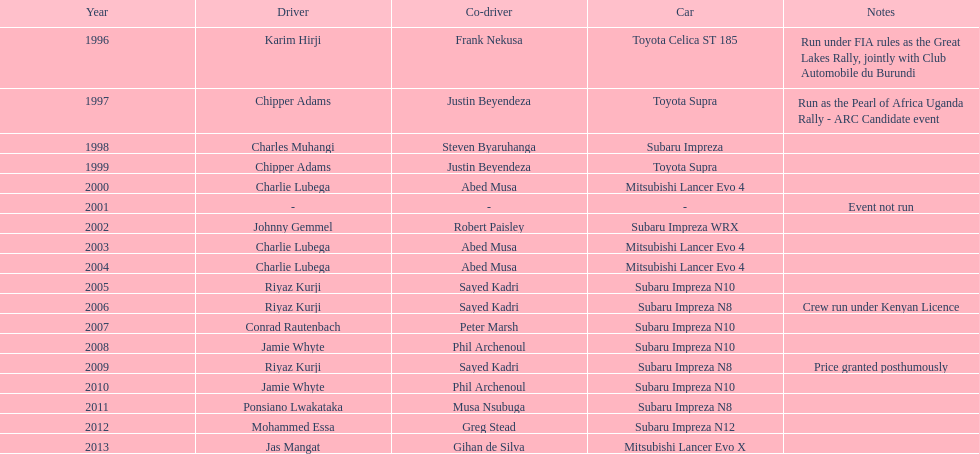Who was the only driver to win in a car other than a subaru impreza after the year 2005? Jas Mangat. 